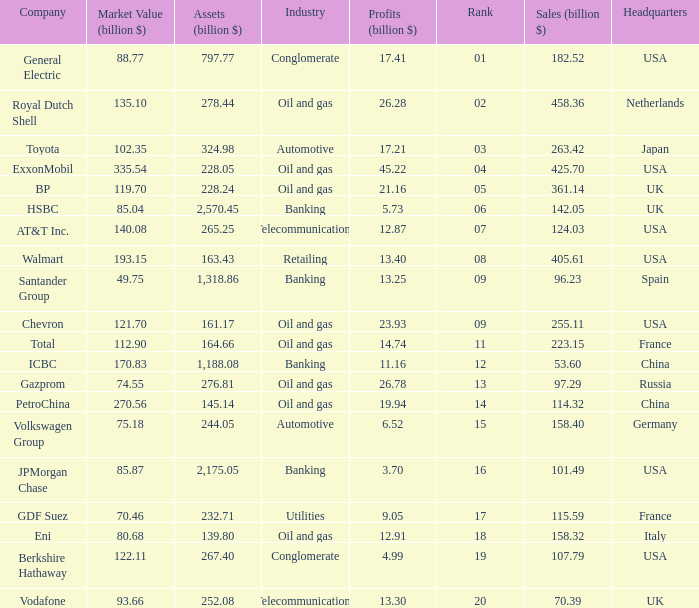Name the lowest Market Value (billion $) which has Assets (billion $) larger than 276.81, and a Company of toyota, and Profits (billion $) larger than 17.21? None. 